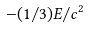<formula> <loc_0><loc_0><loc_500><loc_500>- ( 1 / 3 ) E / c ^ { 2 }</formula> 